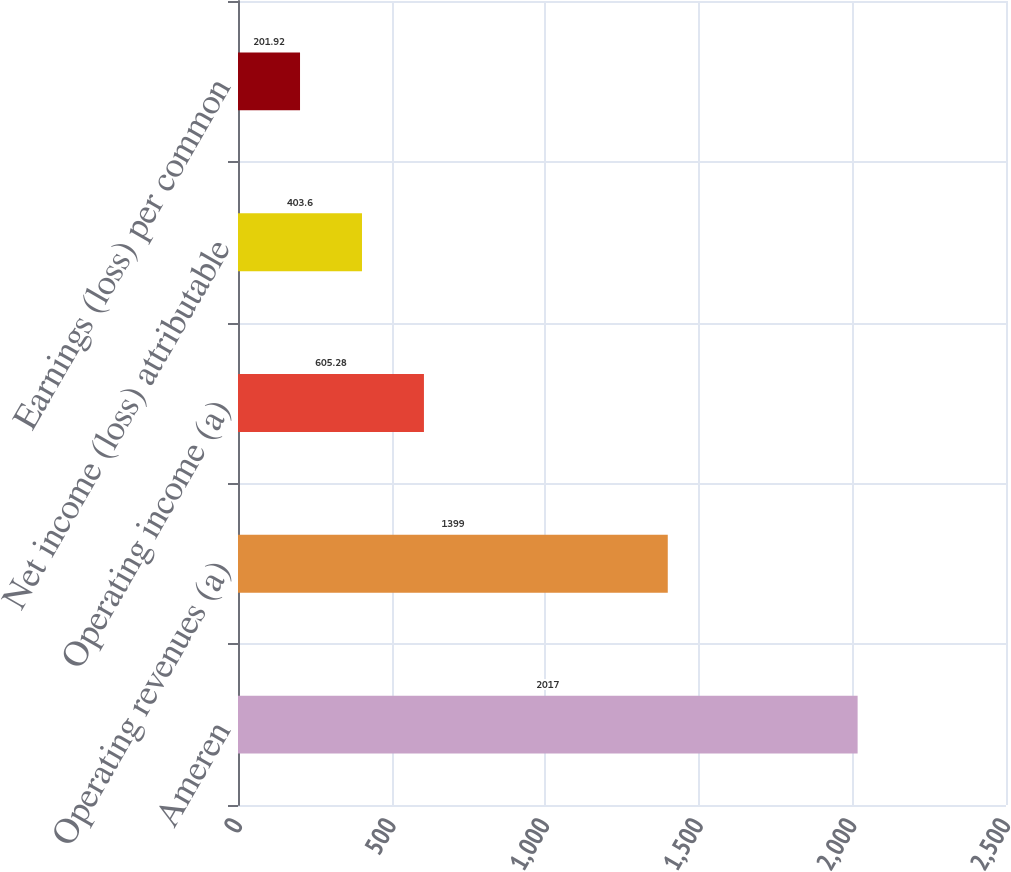<chart> <loc_0><loc_0><loc_500><loc_500><bar_chart><fcel>Ameren<fcel>Operating revenues (a)<fcel>Operating income (a)<fcel>Net income (loss) attributable<fcel>Earnings (loss) per common<nl><fcel>2017<fcel>1399<fcel>605.28<fcel>403.6<fcel>201.92<nl></chart> 